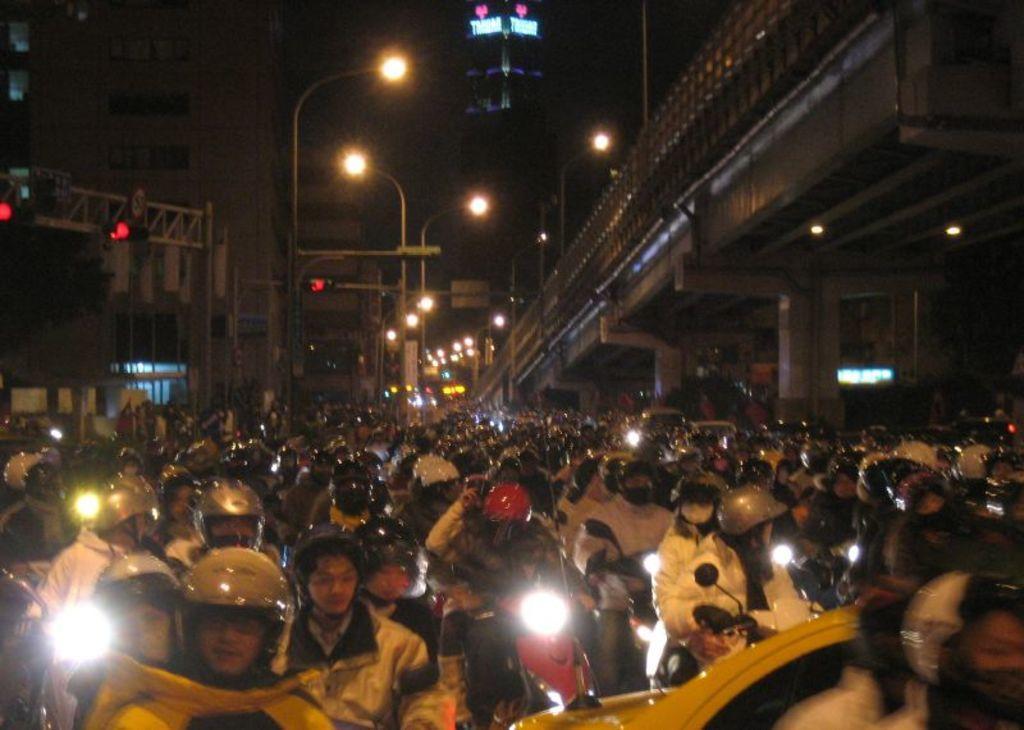Could you give a brief overview of what you see in this image? At the bottom of the image, we can see people are riding vehicles and wearing helmets. In the background, we can see buildings, traffic signals, pillars, tree, bridge and dark view. 